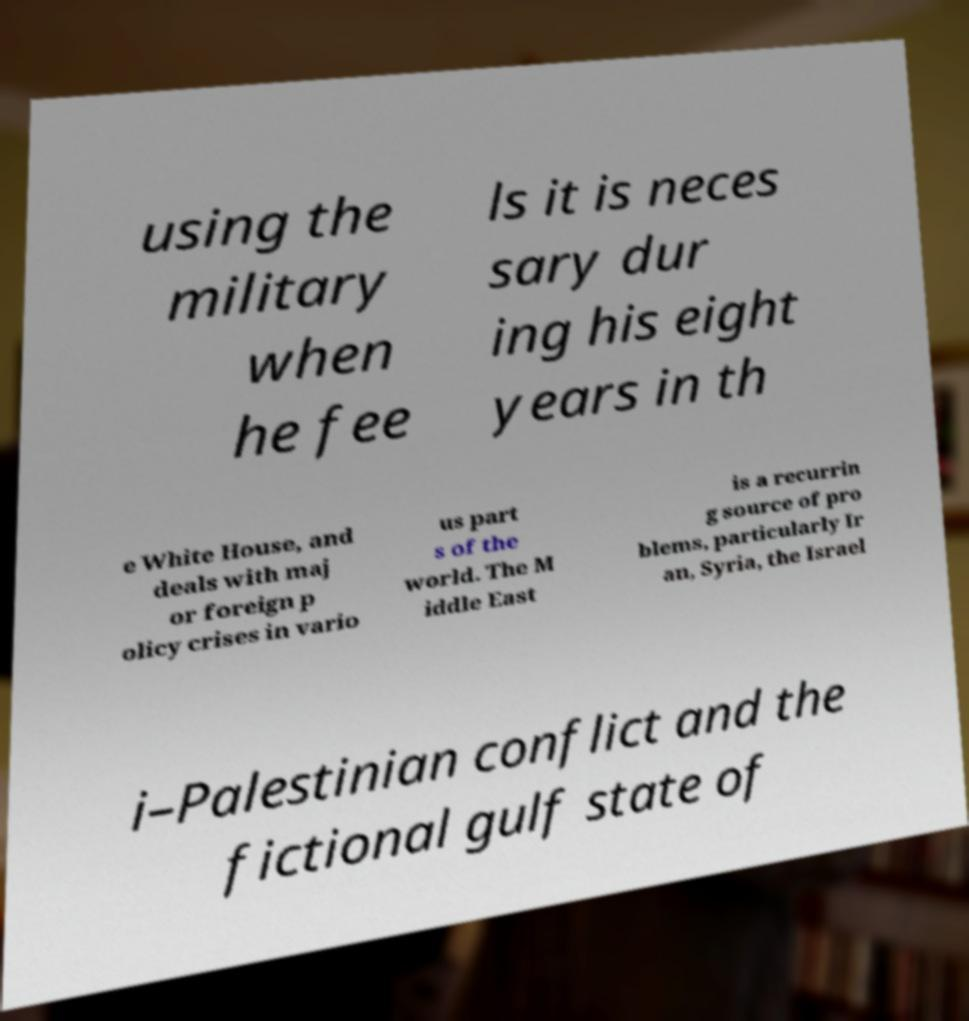For documentation purposes, I need the text within this image transcribed. Could you provide that? using the military when he fee ls it is neces sary dur ing his eight years in th e White House, and deals with maj or foreign p olicy crises in vario us part s of the world. The M iddle East is a recurrin g source of pro blems, particularly Ir an, Syria, the Israel i–Palestinian conflict and the fictional gulf state of 